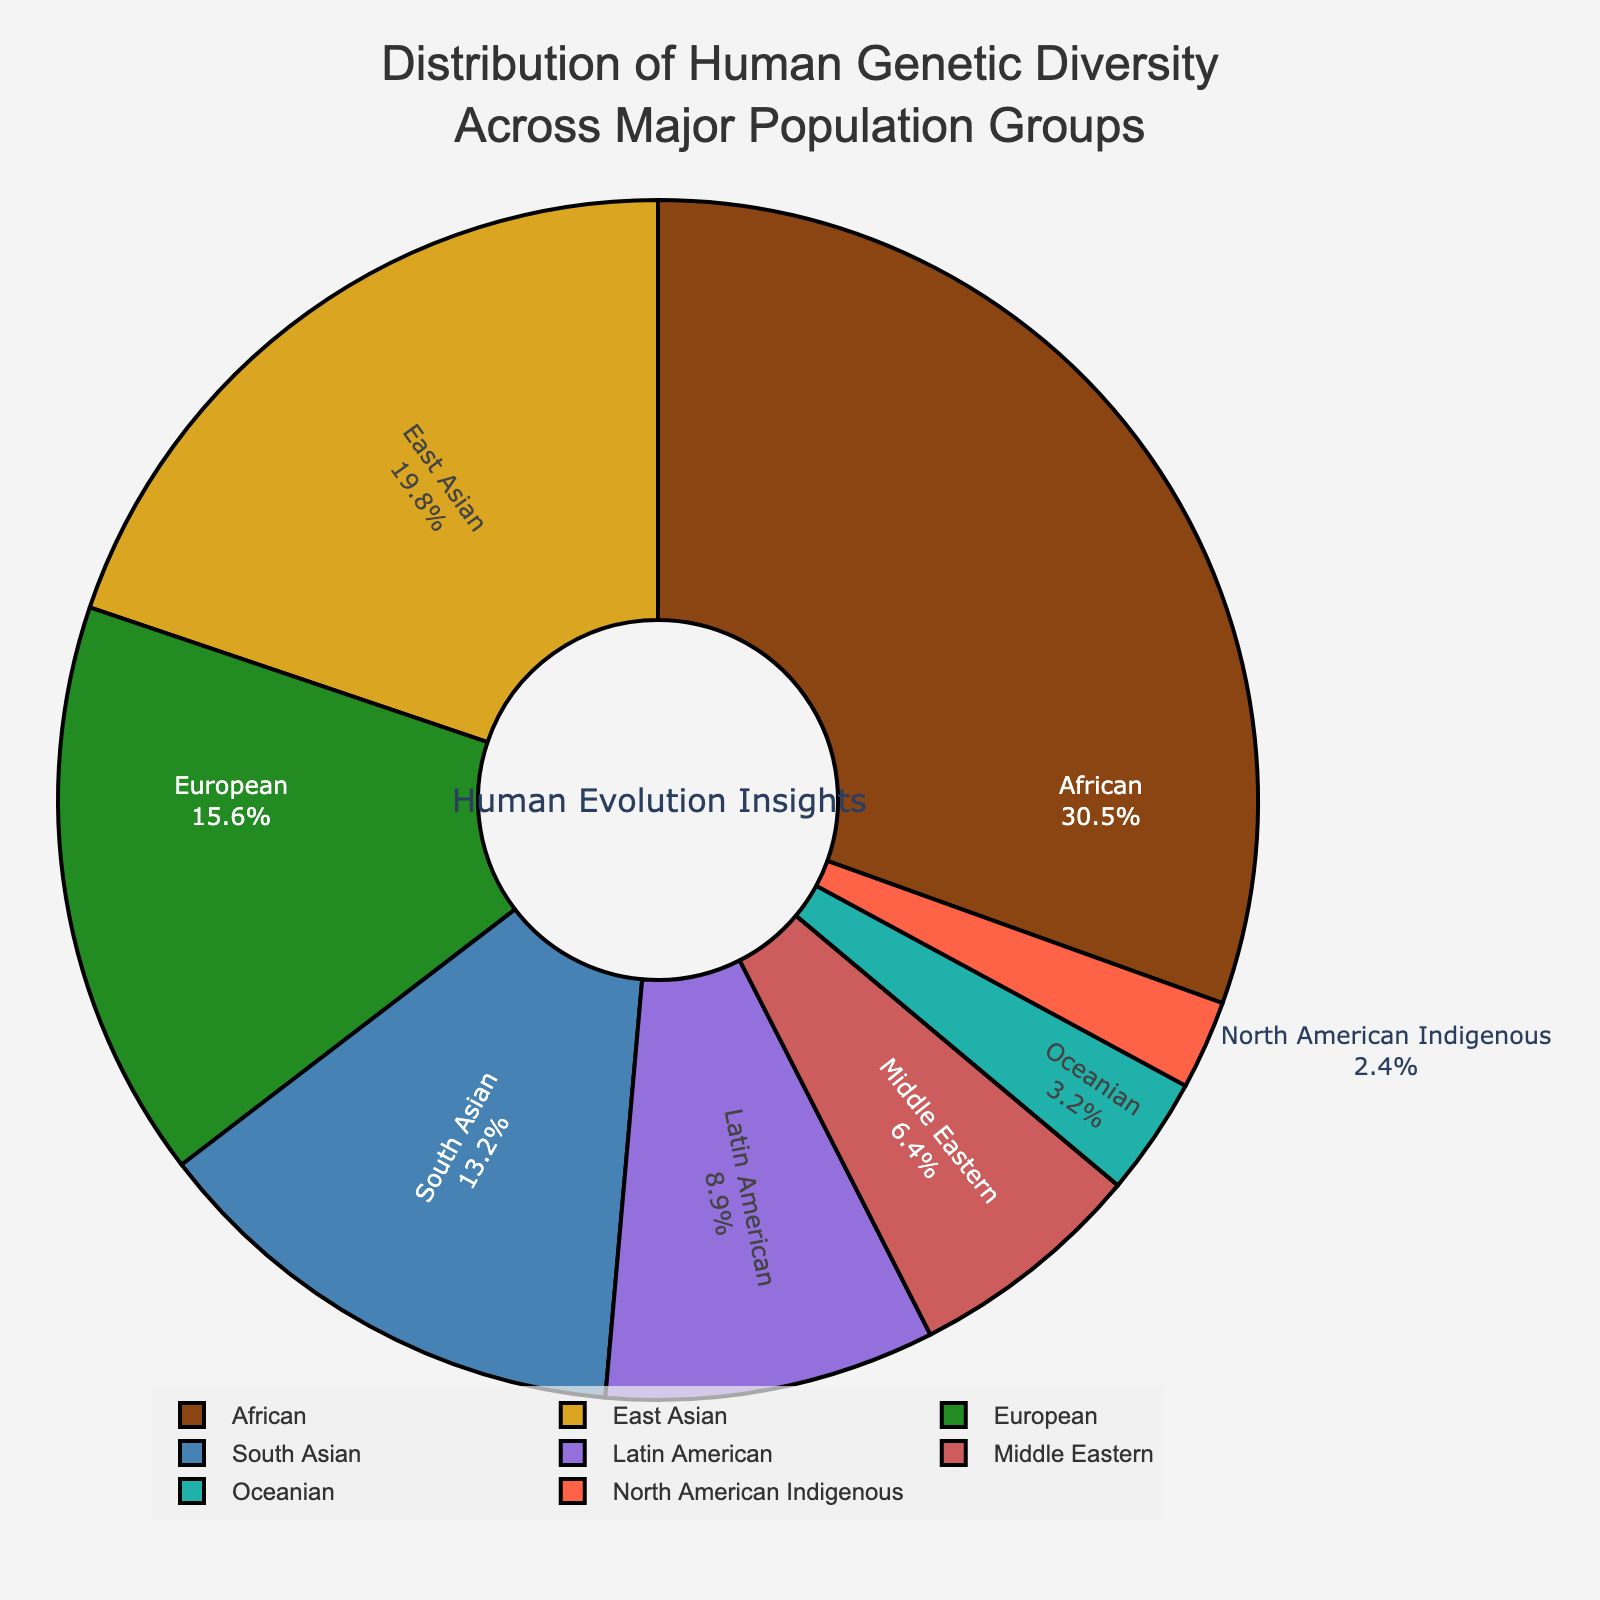What population group has the highest genetic diversity percentage? The pie chart shows that the African population group has the largest section, labeled with "30.5%", making it clear that it has the highest genetic diversity percentage.
Answer: African Which two population groups have the most similar genetic diversity percentages? The pie chart shows the percentages of each population group, and the South Asian group (13.2%) and the Middle Eastern group (6.4%) have the most similar values among the groups listed, with a relatively small difference between them.
Answer: South Asian and Middle Eastern What is the combined genetic diversity percentage of the East Asian and European population groups? The pie chart shows that the East Asian population group has 19.8% and the European population group has 15.6%. Adding these together: 19.8 + 15.6 = 35.4%.
Answer: 35.4% Which population group has the smallest genetic diversity percentage? The pie chart clearly shows that the North American Indigenous group has the smallest section, marked with "2.4%".
Answer: North American Indigenous How much more genetic diversity percentage does the African population group have compared to the Latin American population group? According to the pie chart, the African group has 30.5% and the Latin American group has 8.9%. The difference is calculated as 30.5 - 8.9 = 21.6%.
Answer: 21.6% What is the median value of genetic diversity percentages across all population groups? To find the median, list the values in ascending order: 2.4, 3.2, 6.4, 8.9, 13.2, 15.6, 19.8, 30.5. With 8 values, the median is the average of the 4th and 5th values: (8.9 + 13.2)/2 = 11.05%.
Answer: 11.05% Compare the genetic diversity percentages of South Asian and Oceanian population groups. Which one is larger and by how much? The pie chart shows South Asian at 13.2% and Oceanian at 3.2%. South Asian is larger, and the difference is 13.2 - 3.2 = 10%.
Answer: South Asian, 10% Among African, European, and North American Indigenous population groups, which has the intermediate genetic diversity percentage? The pie chart shows African at 30.5%, European at 15.6%, and North American Indigenous at 2.4%. European falls between the other two.
Answer: European What color is used to represent the East Asian population group in the pie chart? The pie chart is color-coded, and the segment for East Asian is shown in a specific color. Observing the chart, the East Asian group is presented with the color gold.
Answer: Gold What percentage of genetic diversity is not accounted for by African, East Asian, and European groups combined? Summing the genetic diversity percentages of African (30.5%), East Asian (19.8%), and European (15.6%): 30.5 + 19.8 + 15.6 = 65.9%. Therefore, the remaining percentage is 100 - 65.9 = 34.1%.
Answer: 34.1% 